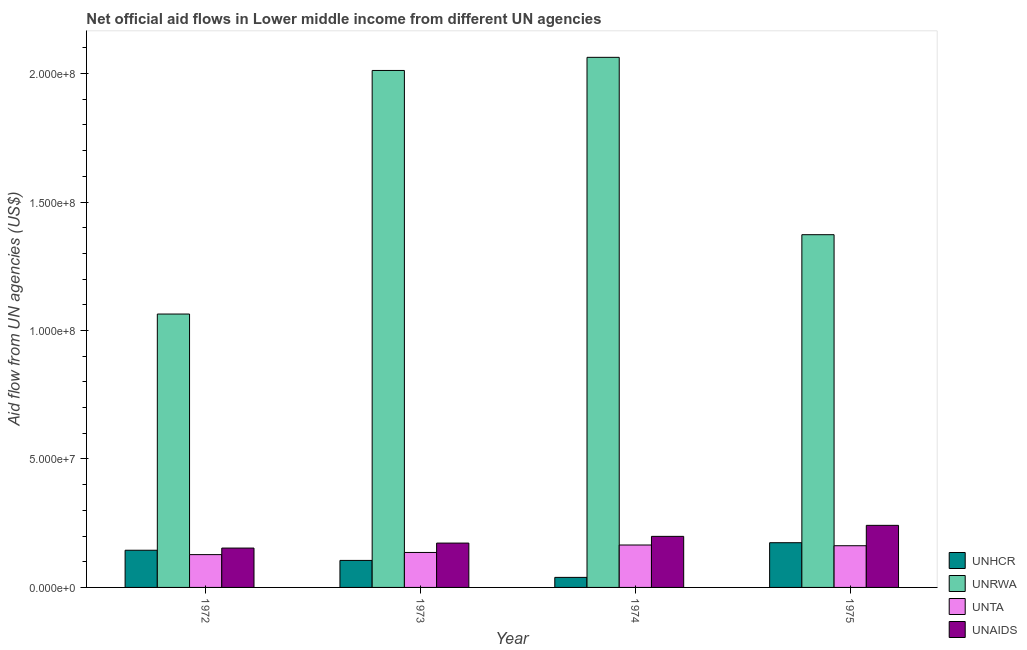How many groups of bars are there?
Keep it short and to the point. 4. Are the number of bars per tick equal to the number of legend labels?
Keep it short and to the point. Yes. Are the number of bars on each tick of the X-axis equal?
Offer a terse response. Yes. How many bars are there on the 2nd tick from the right?
Your answer should be very brief. 4. What is the label of the 3rd group of bars from the left?
Your answer should be very brief. 1974. What is the amount of aid given by unhcr in 1974?
Offer a very short reply. 3.91e+06. Across all years, what is the maximum amount of aid given by unaids?
Provide a short and direct response. 2.42e+07. Across all years, what is the minimum amount of aid given by unta?
Offer a terse response. 1.28e+07. In which year was the amount of aid given by unhcr maximum?
Provide a succinct answer. 1975. In which year was the amount of aid given by unhcr minimum?
Provide a short and direct response. 1974. What is the total amount of aid given by unta in the graph?
Give a very brief answer. 5.91e+07. What is the difference between the amount of aid given by unhcr in 1973 and that in 1974?
Your answer should be compact. 6.60e+06. What is the difference between the amount of aid given by unta in 1974 and the amount of aid given by unhcr in 1973?
Your response must be concise. 2.90e+06. What is the average amount of aid given by unaids per year?
Provide a short and direct response. 1.92e+07. In the year 1974, what is the difference between the amount of aid given by unta and amount of aid given by unaids?
Provide a succinct answer. 0. In how many years, is the amount of aid given by unhcr greater than 120000000 US$?
Ensure brevity in your answer.  0. What is the ratio of the amount of aid given by unrwa in 1973 to that in 1974?
Offer a terse response. 0.98. What is the difference between the highest and the second highest amount of aid given by unhcr?
Keep it short and to the point. 2.93e+06. What is the difference between the highest and the lowest amount of aid given by unhcr?
Your answer should be very brief. 1.35e+07. Is the sum of the amount of aid given by unaids in 1972 and 1973 greater than the maximum amount of aid given by unrwa across all years?
Your answer should be very brief. Yes. Is it the case that in every year, the sum of the amount of aid given by unta and amount of aid given by unhcr is greater than the sum of amount of aid given by unrwa and amount of aid given by unaids?
Make the answer very short. No. What does the 4th bar from the left in 1974 represents?
Offer a terse response. UNAIDS. What does the 1st bar from the right in 1975 represents?
Ensure brevity in your answer.  UNAIDS. How many bars are there?
Ensure brevity in your answer.  16. How many years are there in the graph?
Offer a terse response. 4. Are the values on the major ticks of Y-axis written in scientific E-notation?
Provide a succinct answer. Yes. What is the title of the graph?
Your answer should be very brief. Net official aid flows in Lower middle income from different UN agencies. What is the label or title of the Y-axis?
Offer a very short reply. Aid flow from UN agencies (US$). What is the Aid flow from UN agencies (US$) of UNHCR in 1972?
Your answer should be compact. 1.45e+07. What is the Aid flow from UN agencies (US$) of UNRWA in 1972?
Provide a short and direct response. 1.06e+08. What is the Aid flow from UN agencies (US$) of UNTA in 1972?
Offer a very short reply. 1.28e+07. What is the Aid flow from UN agencies (US$) in UNAIDS in 1972?
Provide a short and direct response. 1.53e+07. What is the Aid flow from UN agencies (US$) of UNHCR in 1973?
Offer a very short reply. 1.05e+07. What is the Aid flow from UN agencies (US$) in UNRWA in 1973?
Your response must be concise. 2.01e+08. What is the Aid flow from UN agencies (US$) of UNTA in 1973?
Offer a very short reply. 1.36e+07. What is the Aid flow from UN agencies (US$) in UNAIDS in 1973?
Provide a short and direct response. 1.73e+07. What is the Aid flow from UN agencies (US$) in UNHCR in 1974?
Ensure brevity in your answer.  3.91e+06. What is the Aid flow from UN agencies (US$) of UNRWA in 1974?
Your response must be concise. 2.06e+08. What is the Aid flow from UN agencies (US$) in UNTA in 1974?
Keep it short and to the point. 1.65e+07. What is the Aid flow from UN agencies (US$) of UNAIDS in 1974?
Make the answer very short. 1.99e+07. What is the Aid flow from UN agencies (US$) in UNHCR in 1975?
Offer a terse response. 1.74e+07. What is the Aid flow from UN agencies (US$) of UNRWA in 1975?
Ensure brevity in your answer.  1.37e+08. What is the Aid flow from UN agencies (US$) in UNTA in 1975?
Your answer should be compact. 1.62e+07. What is the Aid flow from UN agencies (US$) in UNAIDS in 1975?
Ensure brevity in your answer.  2.42e+07. Across all years, what is the maximum Aid flow from UN agencies (US$) in UNHCR?
Keep it short and to the point. 1.74e+07. Across all years, what is the maximum Aid flow from UN agencies (US$) in UNRWA?
Keep it short and to the point. 2.06e+08. Across all years, what is the maximum Aid flow from UN agencies (US$) in UNTA?
Your response must be concise. 1.65e+07. Across all years, what is the maximum Aid flow from UN agencies (US$) of UNAIDS?
Offer a very short reply. 2.42e+07. Across all years, what is the minimum Aid flow from UN agencies (US$) in UNHCR?
Ensure brevity in your answer.  3.91e+06. Across all years, what is the minimum Aid flow from UN agencies (US$) in UNRWA?
Offer a very short reply. 1.06e+08. Across all years, what is the minimum Aid flow from UN agencies (US$) in UNTA?
Offer a very short reply. 1.28e+07. Across all years, what is the minimum Aid flow from UN agencies (US$) in UNAIDS?
Provide a short and direct response. 1.53e+07. What is the total Aid flow from UN agencies (US$) in UNHCR in the graph?
Make the answer very short. 4.63e+07. What is the total Aid flow from UN agencies (US$) in UNRWA in the graph?
Make the answer very short. 6.51e+08. What is the total Aid flow from UN agencies (US$) in UNTA in the graph?
Your answer should be compact. 5.91e+07. What is the total Aid flow from UN agencies (US$) of UNAIDS in the graph?
Your answer should be very brief. 7.66e+07. What is the difference between the Aid flow from UN agencies (US$) of UNHCR in 1972 and that in 1973?
Give a very brief answer. 3.96e+06. What is the difference between the Aid flow from UN agencies (US$) in UNRWA in 1972 and that in 1973?
Your answer should be compact. -9.48e+07. What is the difference between the Aid flow from UN agencies (US$) in UNTA in 1972 and that in 1973?
Your answer should be compact. -8.40e+05. What is the difference between the Aid flow from UN agencies (US$) in UNAIDS in 1972 and that in 1973?
Offer a terse response. -1.94e+06. What is the difference between the Aid flow from UN agencies (US$) in UNHCR in 1972 and that in 1974?
Offer a very short reply. 1.06e+07. What is the difference between the Aid flow from UN agencies (US$) in UNRWA in 1972 and that in 1974?
Provide a succinct answer. -9.99e+07. What is the difference between the Aid flow from UN agencies (US$) of UNTA in 1972 and that in 1974?
Provide a succinct answer. -3.74e+06. What is the difference between the Aid flow from UN agencies (US$) in UNAIDS in 1972 and that in 1974?
Keep it short and to the point. -4.55e+06. What is the difference between the Aid flow from UN agencies (US$) in UNHCR in 1972 and that in 1975?
Give a very brief answer. -2.93e+06. What is the difference between the Aid flow from UN agencies (US$) in UNRWA in 1972 and that in 1975?
Keep it short and to the point. -3.09e+07. What is the difference between the Aid flow from UN agencies (US$) of UNTA in 1972 and that in 1975?
Make the answer very short. -3.46e+06. What is the difference between the Aid flow from UN agencies (US$) of UNAIDS in 1972 and that in 1975?
Provide a short and direct response. -8.84e+06. What is the difference between the Aid flow from UN agencies (US$) of UNHCR in 1973 and that in 1974?
Provide a short and direct response. 6.60e+06. What is the difference between the Aid flow from UN agencies (US$) in UNRWA in 1973 and that in 1974?
Make the answer very short. -5.11e+06. What is the difference between the Aid flow from UN agencies (US$) of UNTA in 1973 and that in 1974?
Offer a terse response. -2.90e+06. What is the difference between the Aid flow from UN agencies (US$) of UNAIDS in 1973 and that in 1974?
Ensure brevity in your answer.  -2.61e+06. What is the difference between the Aid flow from UN agencies (US$) of UNHCR in 1973 and that in 1975?
Provide a short and direct response. -6.89e+06. What is the difference between the Aid flow from UN agencies (US$) of UNRWA in 1973 and that in 1975?
Offer a terse response. 6.39e+07. What is the difference between the Aid flow from UN agencies (US$) in UNTA in 1973 and that in 1975?
Provide a succinct answer. -2.62e+06. What is the difference between the Aid flow from UN agencies (US$) in UNAIDS in 1973 and that in 1975?
Your response must be concise. -6.90e+06. What is the difference between the Aid flow from UN agencies (US$) in UNHCR in 1974 and that in 1975?
Your answer should be very brief. -1.35e+07. What is the difference between the Aid flow from UN agencies (US$) of UNRWA in 1974 and that in 1975?
Your response must be concise. 6.90e+07. What is the difference between the Aid flow from UN agencies (US$) in UNAIDS in 1974 and that in 1975?
Ensure brevity in your answer.  -4.29e+06. What is the difference between the Aid flow from UN agencies (US$) of UNHCR in 1972 and the Aid flow from UN agencies (US$) of UNRWA in 1973?
Provide a short and direct response. -1.87e+08. What is the difference between the Aid flow from UN agencies (US$) in UNHCR in 1972 and the Aid flow from UN agencies (US$) in UNTA in 1973?
Make the answer very short. 8.60e+05. What is the difference between the Aid flow from UN agencies (US$) in UNHCR in 1972 and the Aid flow from UN agencies (US$) in UNAIDS in 1973?
Your answer should be very brief. -2.79e+06. What is the difference between the Aid flow from UN agencies (US$) in UNRWA in 1972 and the Aid flow from UN agencies (US$) in UNTA in 1973?
Provide a succinct answer. 9.28e+07. What is the difference between the Aid flow from UN agencies (US$) in UNRWA in 1972 and the Aid flow from UN agencies (US$) in UNAIDS in 1973?
Your answer should be compact. 8.91e+07. What is the difference between the Aid flow from UN agencies (US$) of UNTA in 1972 and the Aid flow from UN agencies (US$) of UNAIDS in 1973?
Offer a very short reply. -4.49e+06. What is the difference between the Aid flow from UN agencies (US$) in UNHCR in 1972 and the Aid flow from UN agencies (US$) in UNRWA in 1974?
Offer a very short reply. -1.92e+08. What is the difference between the Aid flow from UN agencies (US$) in UNHCR in 1972 and the Aid flow from UN agencies (US$) in UNTA in 1974?
Provide a succinct answer. -2.04e+06. What is the difference between the Aid flow from UN agencies (US$) of UNHCR in 1972 and the Aid flow from UN agencies (US$) of UNAIDS in 1974?
Keep it short and to the point. -5.40e+06. What is the difference between the Aid flow from UN agencies (US$) in UNRWA in 1972 and the Aid flow from UN agencies (US$) in UNTA in 1974?
Give a very brief answer. 8.99e+07. What is the difference between the Aid flow from UN agencies (US$) in UNRWA in 1972 and the Aid flow from UN agencies (US$) in UNAIDS in 1974?
Make the answer very short. 8.65e+07. What is the difference between the Aid flow from UN agencies (US$) of UNTA in 1972 and the Aid flow from UN agencies (US$) of UNAIDS in 1974?
Your answer should be very brief. -7.10e+06. What is the difference between the Aid flow from UN agencies (US$) of UNHCR in 1972 and the Aid flow from UN agencies (US$) of UNRWA in 1975?
Your answer should be very brief. -1.23e+08. What is the difference between the Aid flow from UN agencies (US$) of UNHCR in 1972 and the Aid flow from UN agencies (US$) of UNTA in 1975?
Ensure brevity in your answer.  -1.76e+06. What is the difference between the Aid flow from UN agencies (US$) in UNHCR in 1972 and the Aid flow from UN agencies (US$) in UNAIDS in 1975?
Your answer should be compact. -9.69e+06. What is the difference between the Aid flow from UN agencies (US$) in UNRWA in 1972 and the Aid flow from UN agencies (US$) in UNTA in 1975?
Your answer should be compact. 9.02e+07. What is the difference between the Aid flow from UN agencies (US$) of UNRWA in 1972 and the Aid flow from UN agencies (US$) of UNAIDS in 1975?
Provide a short and direct response. 8.22e+07. What is the difference between the Aid flow from UN agencies (US$) of UNTA in 1972 and the Aid flow from UN agencies (US$) of UNAIDS in 1975?
Keep it short and to the point. -1.14e+07. What is the difference between the Aid flow from UN agencies (US$) of UNHCR in 1973 and the Aid flow from UN agencies (US$) of UNRWA in 1974?
Provide a succinct answer. -1.96e+08. What is the difference between the Aid flow from UN agencies (US$) of UNHCR in 1973 and the Aid flow from UN agencies (US$) of UNTA in 1974?
Give a very brief answer. -6.00e+06. What is the difference between the Aid flow from UN agencies (US$) in UNHCR in 1973 and the Aid flow from UN agencies (US$) in UNAIDS in 1974?
Provide a succinct answer. -9.36e+06. What is the difference between the Aid flow from UN agencies (US$) in UNRWA in 1973 and the Aid flow from UN agencies (US$) in UNTA in 1974?
Offer a terse response. 1.85e+08. What is the difference between the Aid flow from UN agencies (US$) in UNRWA in 1973 and the Aid flow from UN agencies (US$) in UNAIDS in 1974?
Offer a very short reply. 1.81e+08. What is the difference between the Aid flow from UN agencies (US$) in UNTA in 1973 and the Aid flow from UN agencies (US$) in UNAIDS in 1974?
Offer a very short reply. -6.26e+06. What is the difference between the Aid flow from UN agencies (US$) of UNHCR in 1973 and the Aid flow from UN agencies (US$) of UNRWA in 1975?
Provide a succinct answer. -1.27e+08. What is the difference between the Aid flow from UN agencies (US$) in UNHCR in 1973 and the Aid flow from UN agencies (US$) in UNTA in 1975?
Provide a succinct answer. -5.72e+06. What is the difference between the Aid flow from UN agencies (US$) in UNHCR in 1973 and the Aid flow from UN agencies (US$) in UNAIDS in 1975?
Your answer should be very brief. -1.36e+07. What is the difference between the Aid flow from UN agencies (US$) of UNRWA in 1973 and the Aid flow from UN agencies (US$) of UNTA in 1975?
Give a very brief answer. 1.85e+08. What is the difference between the Aid flow from UN agencies (US$) in UNRWA in 1973 and the Aid flow from UN agencies (US$) in UNAIDS in 1975?
Ensure brevity in your answer.  1.77e+08. What is the difference between the Aid flow from UN agencies (US$) in UNTA in 1973 and the Aid flow from UN agencies (US$) in UNAIDS in 1975?
Make the answer very short. -1.06e+07. What is the difference between the Aid flow from UN agencies (US$) of UNHCR in 1974 and the Aid flow from UN agencies (US$) of UNRWA in 1975?
Your answer should be compact. -1.33e+08. What is the difference between the Aid flow from UN agencies (US$) in UNHCR in 1974 and the Aid flow from UN agencies (US$) in UNTA in 1975?
Offer a very short reply. -1.23e+07. What is the difference between the Aid flow from UN agencies (US$) of UNHCR in 1974 and the Aid flow from UN agencies (US$) of UNAIDS in 1975?
Ensure brevity in your answer.  -2.02e+07. What is the difference between the Aid flow from UN agencies (US$) of UNRWA in 1974 and the Aid flow from UN agencies (US$) of UNTA in 1975?
Provide a short and direct response. 1.90e+08. What is the difference between the Aid flow from UN agencies (US$) in UNRWA in 1974 and the Aid flow from UN agencies (US$) in UNAIDS in 1975?
Offer a very short reply. 1.82e+08. What is the difference between the Aid flow from UN agencies (US$) in UNTA in 1974 and the Aid flow from UN agencies (US$) in UNAIDS in 1975?
Your answer should be very brief. -7.65e+06. What is the average Aid flow from UN agencies (US$) of UNHCR per year?
Offer a very short reply. 1.16e+07. What is the average Aid flow from UN agencies (US$) of UNRWA per year?
Make the answer very short. 1.63e+08. What is the average Aid flow from UN agencies (US$) in UNTA per year?
Offer a terse response. 1.48e+07. What is the average Aid flow from UN agencies (US$) in UNAIDS per year?
Provide a short and direct response. 1.92e+07. In the year 1972, what is the difference between the Aid flow from UN agencies (US$) of UNHCR and Aid flow from UN agencies (US$) of UNRWA?
Make the answer very short. -9.19e+07. In the year 1972, what is the difference between the Aid flow from UN agencies (US$) in UNHCR and Aid flow from UN agencies (US$) in UNTA?
Offer a terse response. 1.70e+06. In the year 1972, what is the difference between the Aid flow from UN agencies (US$) of UNHCR and Aid flow from UN agencies (US$) of UNAIDS?
Give a very brief answer. -8.50e+05. In the year 1972, what is the difference between the Aid flow from UN agencies (US$) in UNRWA and Aid flow from UN agencies (US$) in UNTA?
Offer a very short reply. 9.36e+07. In the year 1972, what is the difference between the Aid flow from UN agencies (US$) in UNRWA and Aid flow from UN agencies (US$) in UNAIDS?
Offer a terse response. 9.11e+07. In the year 1972, what is the difference between the Aid flow from UN agencies (US$) in UNTA and Aid flow from UN agencies (US$) in UNAIDS?
Your answer should be very brief. -2.55e+06. In the year 1973, what is the difference between the Aid flow from UN agencies (US$) in UNHCR and Aid flow from UN agencies (US$) in UNRWA?
Provide a short and direct response. -1.91e+08. In the year 1973, what is the difference between the Aid flow from UN agencies (US$) of UNHCR and Aid flow from UN agencies (US$) of UNTA?
Your response must be concise. -3.10e+06. In the year 1973, what is the difference between the Aid flow from UN agencies (US$) of UNHCR and Aid flow from UN agencies (US$) of UNAIDS?
Keep it short and to the point. -6.75e+06. In the year 1973, what is the difference between the Aid flow from UN agencies (US$) in UNRWA and Aid flow from UN agencies (US$) in UNTA?
Provide a short and direct response. 1.88e+08. In the year 1973, what is the difference between the Aid flow from UN agencies (US$) in UNRWA and Aid flow from UN agencies (US$) in UNAIDS?
Offer a very short reply. 1.84e+08. In the year 1973, what is the difference between the Aid flow from UN agencies (US$) in UNTA and Aid flow from UN agencies (US$) in UNAIDS?
Your answer should be compact. -3.65e+06. In the year 1974, what is the difference between the Aid flow from UN agencies (US$) of UNHCR and Aid flow from UN agencies (US$) of UNRWA?
Make the answer very short. -2.02e+08. In the year 1974, what is the difference between the Aid flow from UN agencies (US$) of UNHCR and Aid flow from UN agencies (US$) of UNTA?
Provide a succinct answer. -1.26e+07. In the year 1974, what is the difference between the Aid flow from UN agencies (US$) in UNHCR and Aid flow from UN agencies (US$) in UNAIDS?
Make the answer very short. -1.60e+07. In the year 1974, what is the difference between the Aid flow from UN agencies (US$) of UNRWA and Aid flow from UN agencies (US$) of UNTA?
Offer a very short reply. 1.90e+08. In the year 1974, what is the difference between the Aid flow from UN agencies (US$) in UNRWA and Aid flow from UN agencies (US$) in UNAIDS?
Make the answer very short. 1.86e+08. In the year 1974, what is the difference between the Aid flow from UN agencies (US$) of UNTA and Aid flow from UN agencies (US$) of UNAIDS?
Your response must be concise. -3.36e+06. In the year 1975, what is the difference between the Aid flow from UN agencies (US$) of UNHCR and Aid flow from UN agencies (US$) of UNRWA?
Provide a short and direct response. -1.20e+08. In the year 1975, what is the difference between the Aid flow from UN agencies (US$) of UNHCR and Aid flow from UN agencies (US$) of UNTA?
Your answer should be compact. 1.17e+06. In the year 1975, what is the difference between the Aid flow from UN agencies (US$) of UNHCR and Aid flow from UN agencies (US$) of UNAIDS?
Give a very brief answer. -6.76e+06. In the year 1975, what is the difference between the Aid flow from UN agencies (US$) in UNRWA and Aid flow from UN agencies (US$) in UNTA?
Your answer should be compact. 1.21e+08. In the year 1975, what is the difference between the Aid flow from UN agencies (US$) of UNRWA and Aid flow from UN agencies (US$) of UNAIDS?
Provide a succinct answer. 1.13e+08. In the year 1975, what is the difference between the Aid flow from UN agencies (US$) of UNTA and Aid flow from UN agencies (US$) of UNAIDS?
Your response must be concise. -7.93e+06. What is the ratio of the Aid flow from UN agencies (US$) in UNHCR in 1972 to that in 1973?
Offer a terse response. 1.38. What is the ratio of the Aid flow from UN agencies (US$) in UNRWA in 1972 to that in 1973?
Give a very brief answer. 0.53. What is the ratio of the Aid flow from UN agencies (US$) in UNTA in 1972 to that in 1973?
Make the answer very short. 0.94. What is the ratio of the Aid flow from UN agencies (US$) of UNAIDS in 1972 to that in 1973?
Your answer should be compact. 0.89. What is the ratio of the Aid flow from UN agencies (US$) in UNHCR in 1972 to that in 1974?
Your response must be concise. 3.7. What is the ratio of the Aid flow from UN agencies (US$) in UNRWA in 1972 to that in 1974?
Provide a succinct answer. 0.52. What is the ratio of the Aid flow from UN agencies (US$) in UNTA in 1972 to that in 1974?
Ensure brevity in your answer.  0.77. What is the ratio of the Aid flow from UN agencies (US$) of UNAIDS in 1972 to that in 1974?
Ensure brevity in your answer.  0.77. What is the ratio of the Aid flow from UN agencies (US$) of UNHCR in 1972 to that in 1975?
Offer a terse response. 0.83. What is the ratio of the Aid flow from UN agencies (US$) in UNRWA in 1972 to that in 1975?
Ensure brevity in your answer.  0.78. What is the ratio of the Aid flow from UN agencies (US$) in UNTA in 1972 to that in 1975?
Your response must be concise. 0.79. What is the ratio of the Aid flow from UN agencies (US$) of UNAIDS in 1972 to that in 1975?
Make the answer very short. 0.63. What is the ratio of the Aid flow from UN agencies (US$) in UNHCR in 1973 to that in 1974?
Provide a short and direct response. 2.69. What is the ratio of the Aid flow from UN agencies (US$) of UNRWA in 1973 to that in 1974?
Your answer should be compact. 0.98. What is the ratio of the Aid flow from UN agencies (US$) in UNTA in 1973 to that in 1974?
Give a very brief answer. 0.82. What is the ratio of the Aid flow from UN agencies (US$) of UNAIDS in 1973 to that in 1974?
Your answer should be compact. 0.87. What is the ratio of the Aid flow from UN agencies (US$) of UNHCR in 1973 to that in 1975?
Provide a succinct answer. 0.6. What is the ratio of the Aid flow from UN agencies (US$) in UNRWA in 1973 to that in 1975?
Offer a very short reply. 1.47. What is the ratio of the Aid flow from UN agencies (US$) in UNTA in 1973 to that in 1975?
Keep it short and to the point. 0.84. What is the ratio of the Aid flow from UN agencies (US$) in UNAIDS in 1973 to that in 1975?
Your response must be concise. 0.71. What is the ratio of the Aid flow from UN agencies (US$) of UNHCR in 1974 to that in 1975?
Provide a short and direct response. 0.22. What is the ratio of the Aid flow from UN agencies (US$) of UNRWA in 1974 to that in 1975?
Your answer should be compact. 1.5. What is the ratio of the Aid flow from UN agencies (US$) in UNTA in 1974 to that in 1975?
Make the answer very short. 1.02. What is the ratio of the Aid flow from UN agencies (US$) in UNAIDS in 1974 to that in 1975?
Ensure brevity in your answer.  0.82. What is the difference between the highest and the second highest Aid flow from UN agencies (US$) in UNHCR?
Keep it short and to the point. 2.93e+06. What is the difference between the highest and the second highest Aid flow from UN agencies (US$) of UNRWA?
Offer a very short reply. 5.11e+06. What is the difference between the highest and the second highest Aid flow from UN agencies (US$) in UNAIDS?
Offer a terse response. 4.29e+06. What is the difference between the highest and the lowest Aid flow from UN agencies (US$) in UNHCR?
Provide a succinct answer. 1.35e+07. What is the difference between the highest and the lowest Aid flow from UN agencies (US$) in UNRWA?
Your answer should be compact. 9.99e+07. What is the difference between the highest and the lowest Aid flow from UN agencies (US$) in UNTA?
Offer a terse response. 3.74e+06. What is the difference between the highest and the lowest Aid flow from UN agencies (US$) of UNAIDS?
Provide a succinct answer. 8.84e+06. 